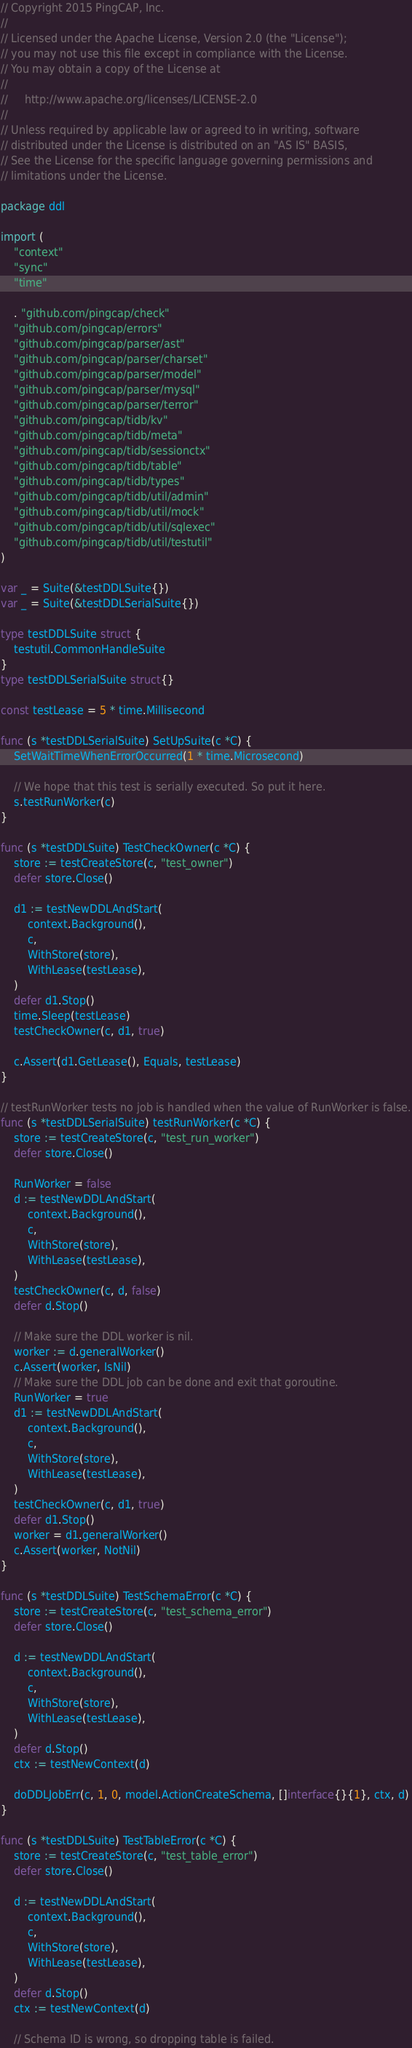Convert code to text. <code><loc_0><loc_0><loc_500><loc_500><_Go_>// Copyright 2015 PingCAP, Inc.
//
// Licensed under the Apache License, Version 2.0 (the "License");
// you may not use this file except in compliance with the License.
// You may obtain a copy of the License at
//
//     http://www.apache.org/licenses/LICENSE-2.0
//
// Unless required by applicable law or agreed to in writing, software
// distributed under the License is distributed on an "AS IS" BASIS,
// See the License for the specific language governing permissions and
// limitations under the License.

package ddl

import (
	"context"
	"sync"
	"time"

	. "github.com/pingcap/check"
	"github.com/pingcap/errors"
	"github.com/pingcap/parser/ast"
	"github.com/pingcap/parser/charset"
	"github.com/pingcap/parser/model"
	"github.com/pingcap/parser/mysql"
	"github.com/pingcap/parser/terror"
	"github.com/pingcap/tidb/kv"
	"github.com/pingcap/tidb/meta"
	"github.com/pingcap/tidb/sessionctx"
	"github.com/pingcap/tidb/table"
	"github.com/pingcap/tidb/types"
	"github.com/pingcap/tidb/util/admin"
	"github.com/pingcap/tidb/util/mock"
	"github.com/pingcap/tidb/util/sqlexec"
	"github.com/pingcap/tidb/util/testutil"
)

var _ = Suite(&testDDLSuite{})
var _ = Suite(&testDDLSerialSuite{})

type testDDLSuite struct {
	testutil.CommonHandleSuite
}
type testDDLSerialSuite struct{}

const testLease = 5 * time.Millisecond

func (s *testDDLSerialSuite) SetUpSuite(c *C) {
	SetWaitTimeWhenErrorOccurred(1 * time.Microsecond)

	// We hope that this test is serially executed. So put it here.
	s.testRunWorker(c)
}

func (s *testDDLSuite) TestCheckOwner(c *C) {
	store := testCreateStore(c, "test_owner")
	defer store.Close()

	d1 := testNewDDLAndStart(
		context.Background(),
		c,
		WithStore(store),
		WithLease(testLease),
	)
	defer d1.Stop()
	time.Sleep(testLease)
	testCheckOwner(c, d1, true)

	c.Assert(d1.GetLease(), Equals, testLease)
}

// testRunWorker tests no job is handled when the value of RunWorker is false.
func (s *testDDLSerialSuite) testRunWorker(c *C) {
	store := testCreateStore(c, "test_run_worker")
	defer store.Close()

	RunWorker = false
	d := testNewDDLAndStart(
		context.Background(),
		c,
		WithStore(store),
		WithLease(testLease),
	)
	testCheckOwner(c, d, false)
	defer d.Stop()

	// Make sure the DDL worker is nil.
	worker := d.generalWorker()
	c.Assert(worker, IsNil)
	// Make sure the DDL job can be done and exit that goroutine.
	RunWorker = true
	d1 := testNewDDLAndStart(
		context.Background(),
		c,
		WithStore(store),
		WithLease(testLease),
	)
	testCheckOwner(c, d1, true)
	defer d1.Stop()
	worker = d1.generalWorker()
	c.Assert(worker, NotNil)
}

func (s *testDDLSuite) TestSchemaError(c *C) {
	store := testCreateStore(c, "test_schema_error")
	defer store.Close()

	d := testNewDDLAndStart(
		context.Background(),
		c,
		WithStore(store),
		WithLease(testLease),
	)
	defer d.Stop()
	ctx := testNewContext(d)

	doDDLJobErr(c, 1, 0, model.ActionCreateSchema, []interface{}{1}, ctx, d)
}

func (s *testDDLSuite) TestTableError(c *C) {
	store := testCreateStore(c, "test_table_error")
	defer store.Close()

	d := testNewDDLAndStart(
		context.Background(),
		c,
		WithStore(store),
		WithLease(testLease),
	)
	defer d.Stop()
	ctx := testNewContext(d)

	// Schema ID is wrong, so dropping table is failed.</code> 